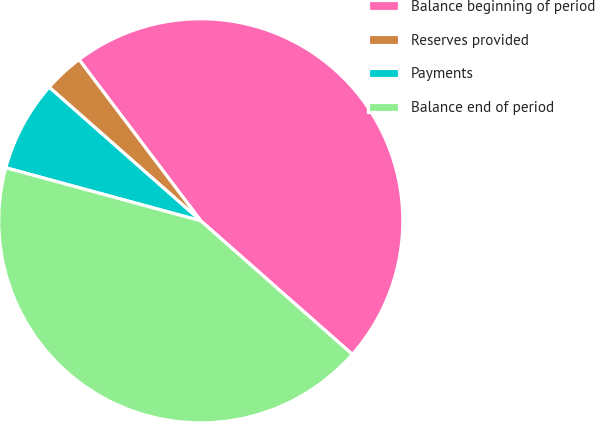Convert chart to OTSL. <chart><loc_0><loc_0><loc_500><loc_500><pie_chart><fcel>Balance beginning of period<fcel>Reserves provided<fcel>Payments<fcel>Balance end of period<nl><fcel>46.79%<fcel>3.21%<fcel>7.27%<fcel>42.73%<nl></chart> 